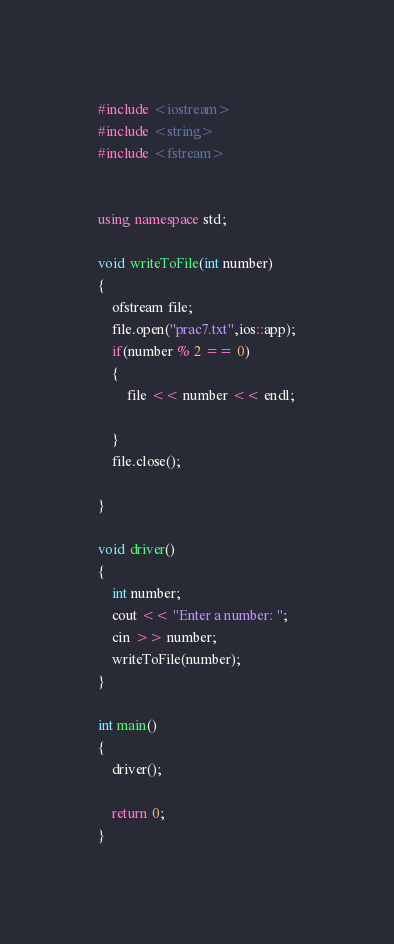<code> <loc_0><loc_0><loc_500><loc_500><_C++_>#include <iostream>
#include <string>
#include <fstream>


using namespace std;

void writeToFile(int number)
{
    ofstream file;
    file.open("prac7.txt",ios::app);
    if(number % 2 == 0)
    {
        file << number << endl;

    }
    file.close();

}

void driver()
{
    int number;
    cout << "Enter a number: ";
    cin >> number;
    writeToFile(number);
}

int main()
{
    driver();

    return 0;
}
</code> 